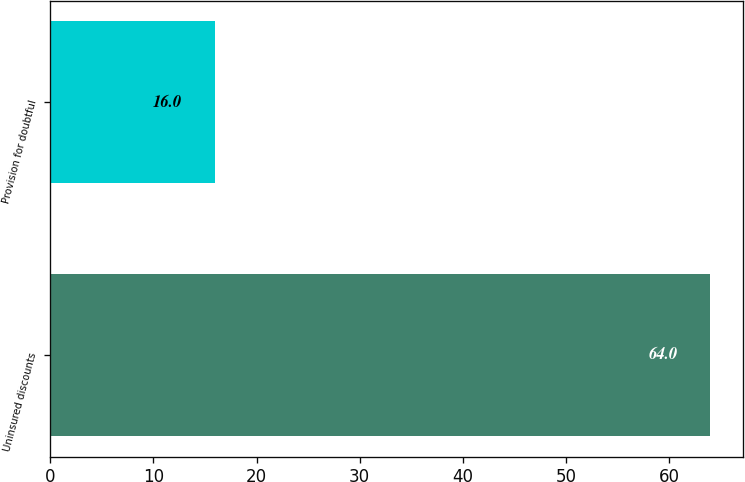Convert chart. <chart><loc_0><loc_0><loc_500><loc_500><bar_chart><fcel>Uninsured discounts<fcel>Provision for doubtful<nl><fcel>64<fcel>16<nl></chart> 